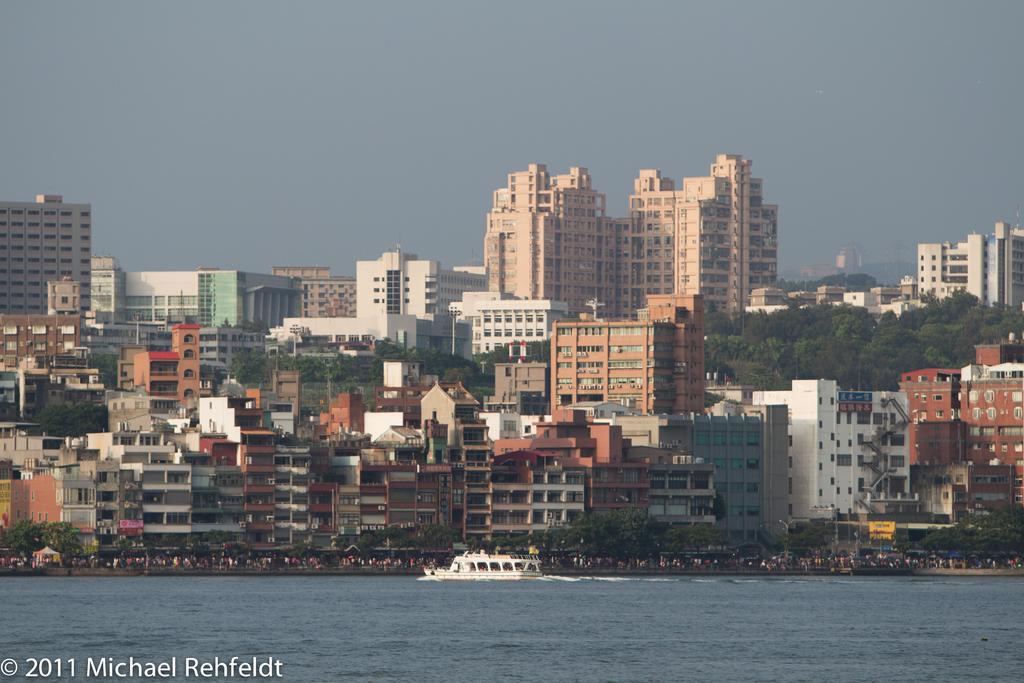In one or two sentences, can you explain what this image depicts? In this picture, we can see a few buildings with windows and we can see water and a boat on it, water, a few people, trees and the sky. 